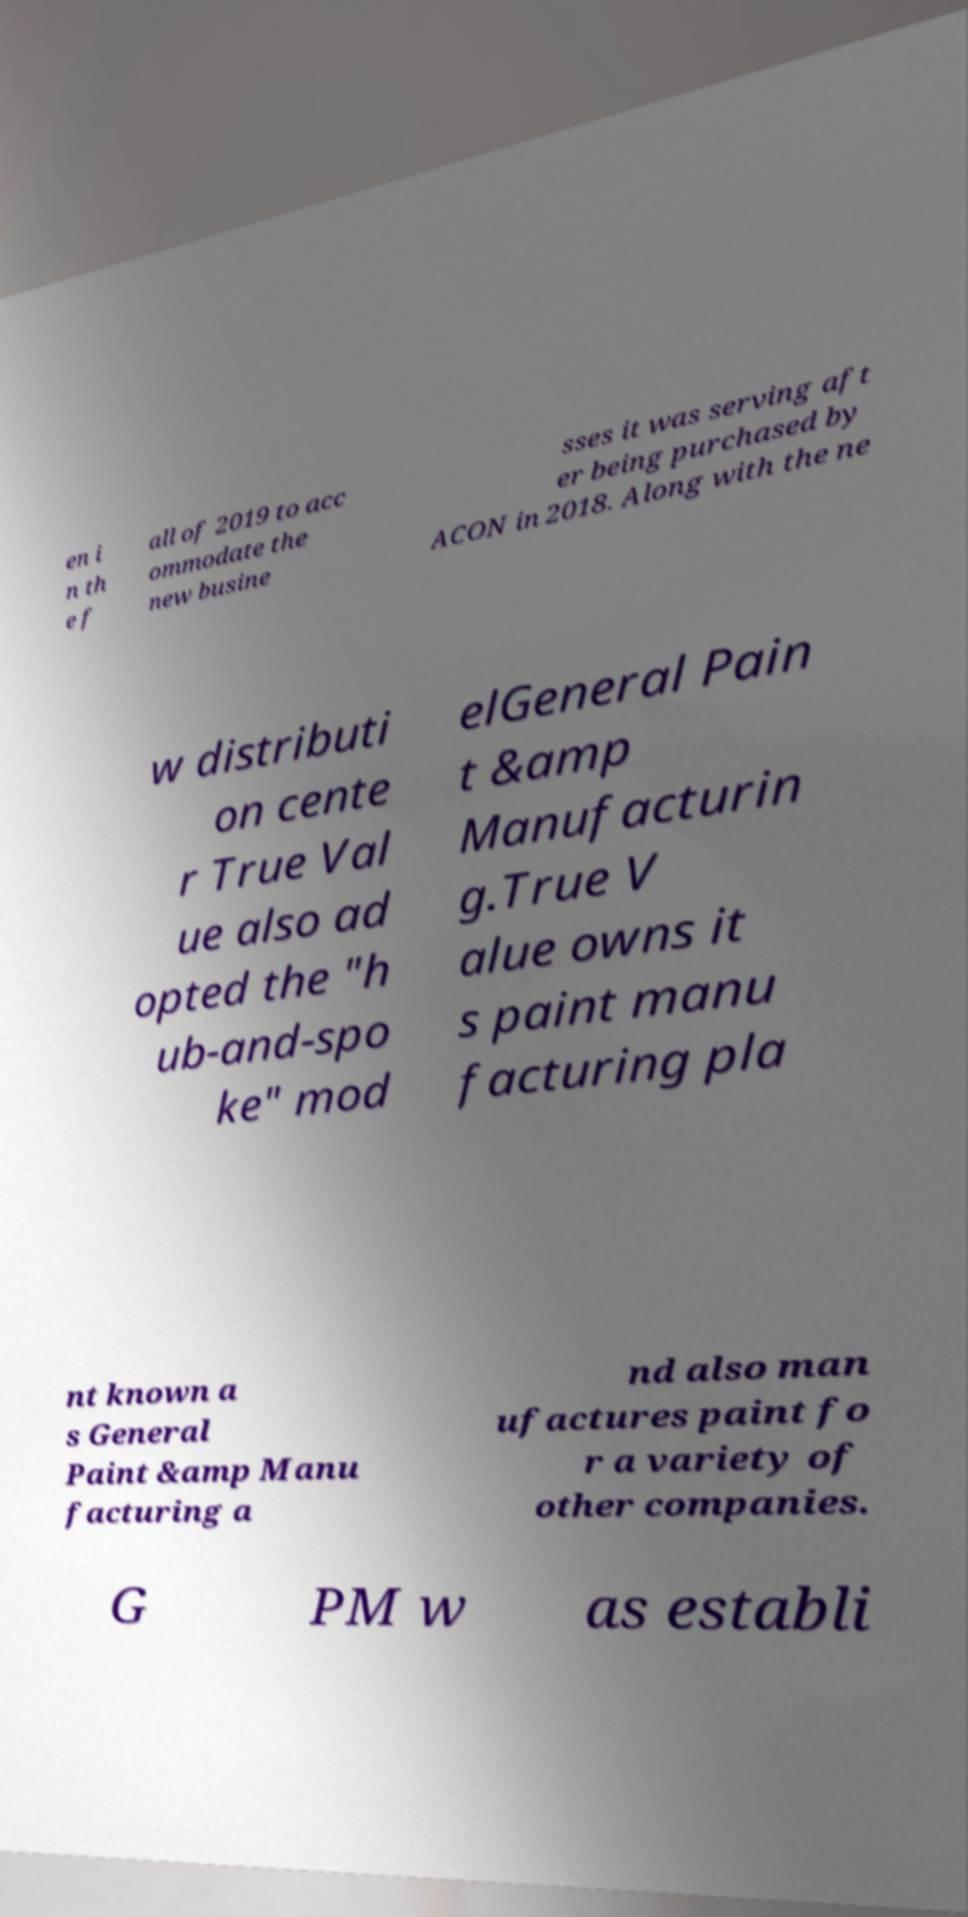Please identify and transcribe the text found in this image. en i n th e f all of 2019 to acc ommodate the new busine sses it was serving aft er being purchased by ACON in 2018. Along with the ne w distributi on cente r True Val ue also ad opted the "h ub-and-spo ke" mod elGeneral Pain t &amp Manufacturin g.True V alue owns it s paint manu facturing pla nt known a s General Paint &amp Manu facturing a nd also man ufactures paint fo r a variety of other companies. G PM w as establi 